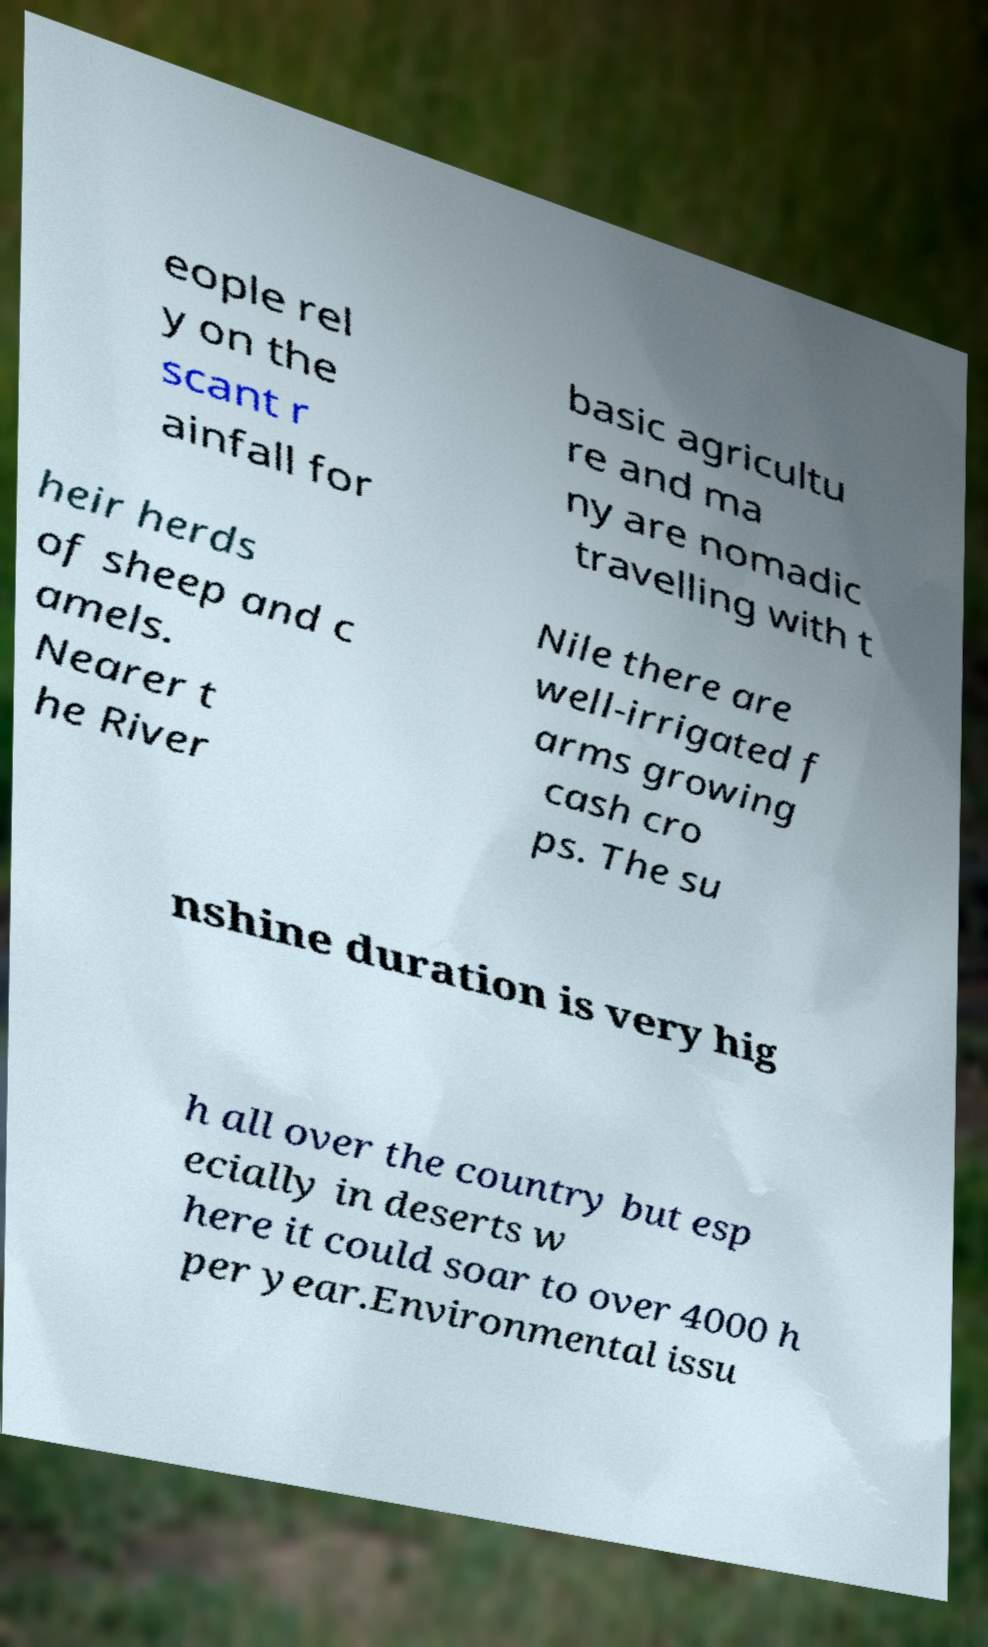Please read and relay the text visible in this image. What does it say? eople rel y on the scant r ainfall for basic agricultu re and ma ny are nomadic travelling with t heir herds of sheep and c amels. Nearer t he River Nile there are well-irrigated f arms growing cash cro ps. The su nshine duration is very hig h all over the country but esp ecially in deserts w here it could soar to over 4000 h per year.Environmental issu 